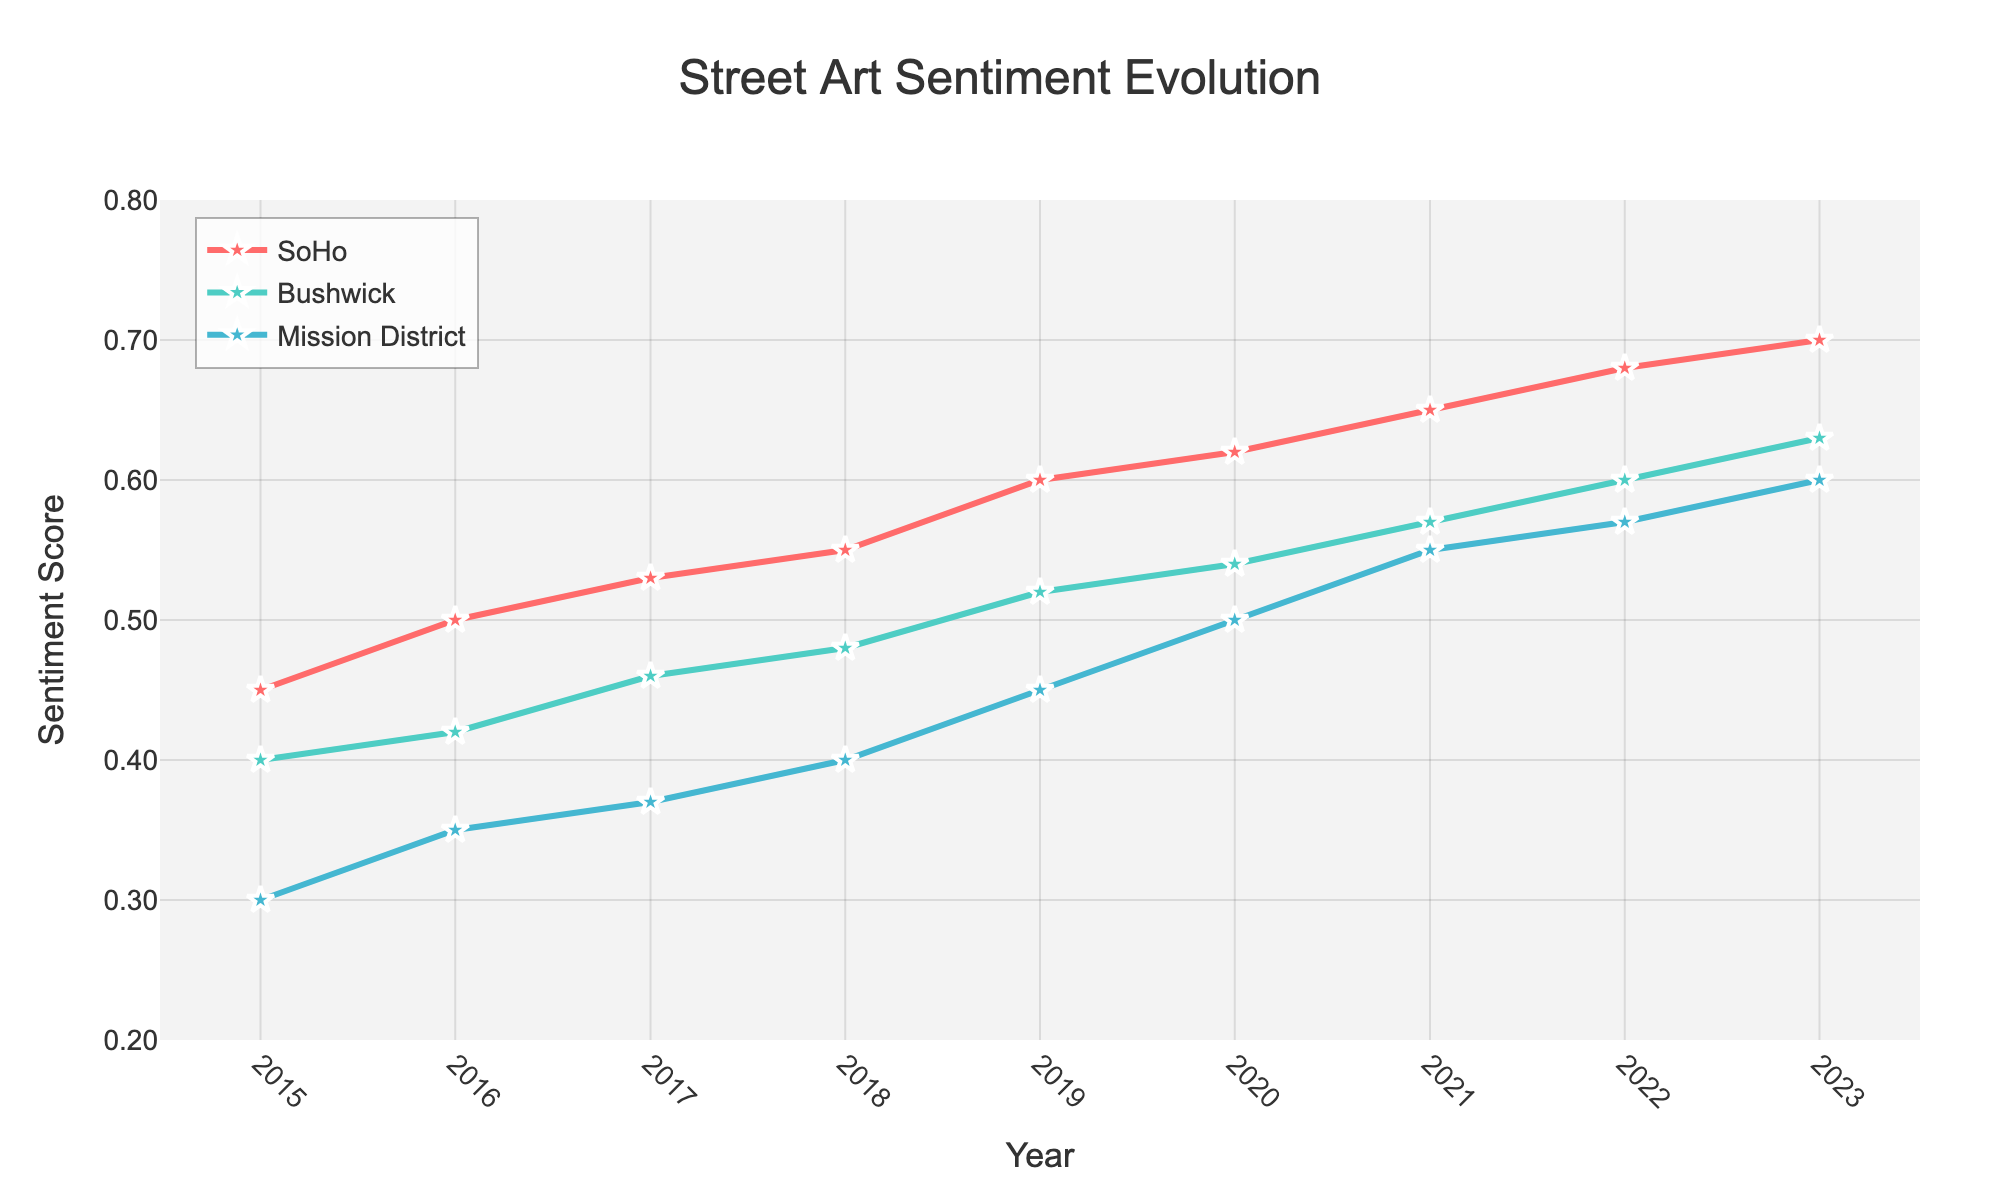What is the title of the plot? The title is clearly displayed at the top center of the plot. It serves to give an overview of what the plot is about.
Answer: Street Art Sentiment Evolution Which neighborhood has the highest sentiment score in 2023? Observe the data points for the year 2023 across all neighborhoods and compare their sentiment scores. The neighborhood with the highest score will stand out.
Answer: SoHo How many neighborhoods are tracked in the plot? Look at the legend or the different traces in the plot. Each neighborhood is represented by a distinct line and label.
Answer: Three By how much did the sentiment score in Bushwick change from 2015 to 2020? Find the sentiment scores for Bushwick in 2015 and 2020 in the plot, then subtract the 2015 score from the 2020 score.
Answer: 0.14 Which neighborhood shows the most consistent increase in sentiment score over the years? Examine the slopes of the lines for each neighborhood. The neighborhood with the most consistently upward trend indicates a consistent increase.
Answer: SoHo What is the sentiment score for Mission District in 2017? Locate the data point for Mission District for the year 2017 on the x-axis and read the corresponding y-value.
Answer: 0.37 Compare the sentiment scores between SoHo and Mission District in 2021. Which one is higher and by how much? Look at the data points for SoHo and Mission District for the year 2021 and compare their y-values. The difference in scores can be calculated by subtraction.
Answer: SoHo, by 0.10 What pattern can be observed in the sentiment scores of Bushwick from 2018 to 2023? Examine the trajectory of Bushwick's sentiment scores over the years 2018 to 2023 to describe any noticeable trends or patterns.
Answer: Upward trend Calculate the average sentiment score for the SoHo neighborhood from 2015 to 2023. Add up all the sentiment scores for SoHo from 2015 to 2023 and divide by the number of years (9).
Answer: 0.584 